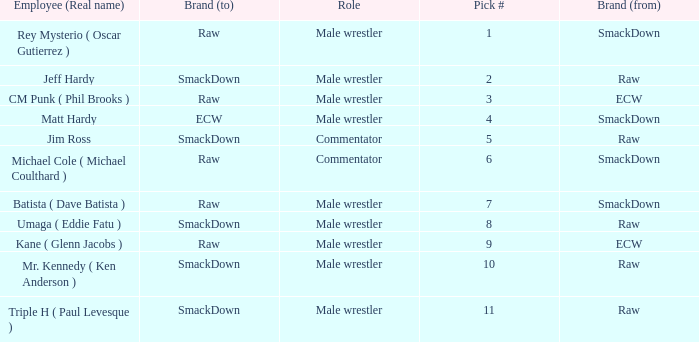What is the real name of the Pick # that is greater than 9? Mr. Kennedy ( Ken Anderson ), Triple H ( Paul Levesque ). 